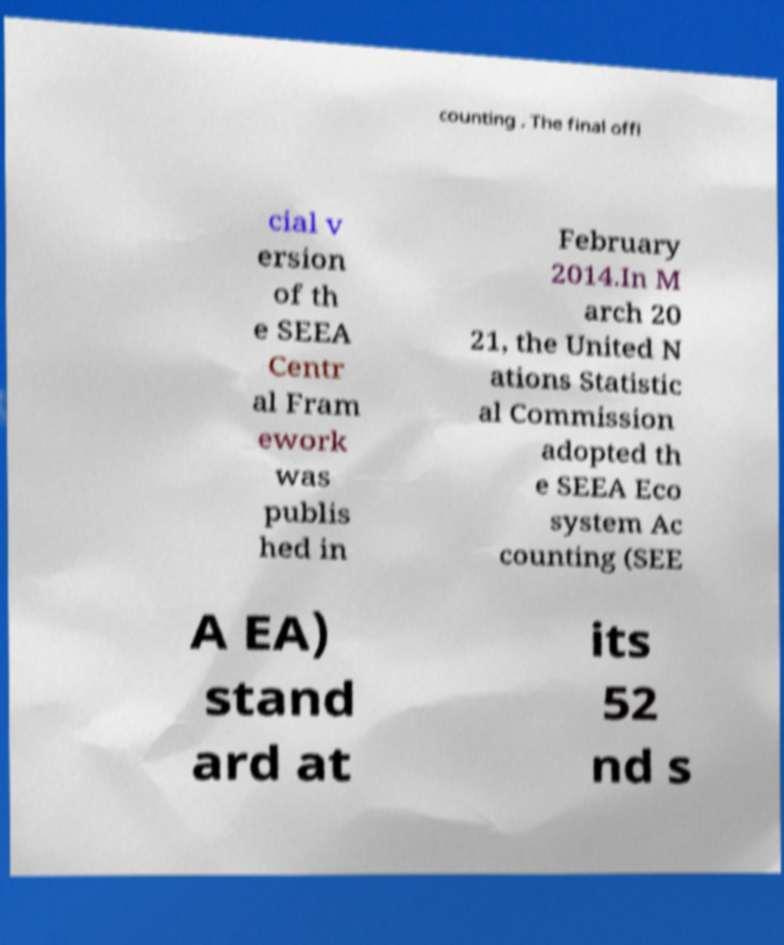For documentation purposes, I need the text within this image transcribed. Could you provide that? counting . The final offi cial v ersion of th e SEEA Centr al Fram ework was publis hed in February 2014.In M arch 20 21, the United N ations Statistic al Commission adopted th e SEEA Eco system Ac counting (SEE A EA) stand ard at its 52 nd s 